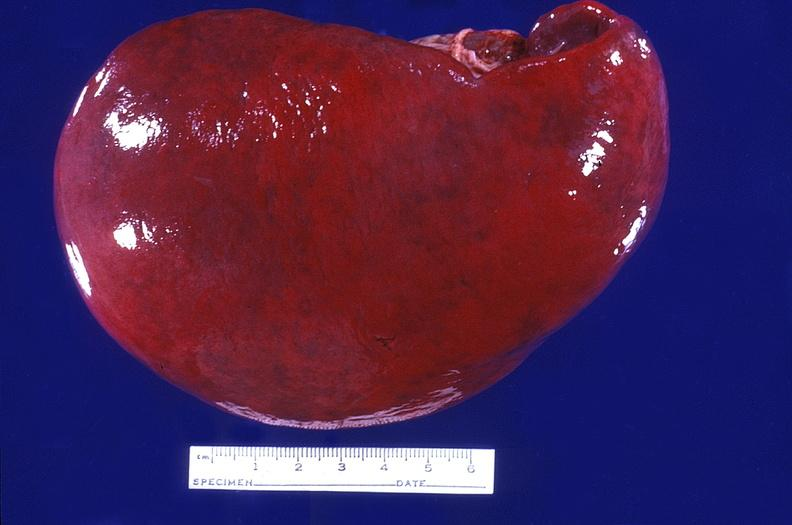where is this part in?
Answer the question using a single word or phrase. Spleen 